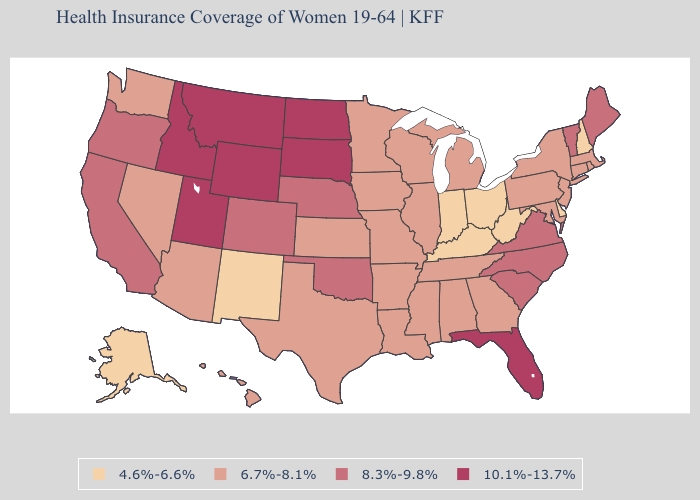Is the legend a continuous bar?
Short answer required. No. Name the states that have a value in the range 10.1%-13.7%?
Answer briefly. Florida, Idaho, Montana, North Dakota, South Dakota, Utah, Wyoming. What is the lowest value in the USA?
Keep it brief. 4.6%-6.6%. Name the states that have a value in the range 4.6%-6.6%?
Keep it brief. Alaska, Delaware, Indiana, Kentucky, New Hampshire, New Mexico, Ohio, West Virginia. What is the value of Delaware?
Give a very brief answer. 4.6%-6.6%. What is the highest value in the USA?
Be succinct. 10.1%-13.7%. Name the states that have a value in the range 6.7%-8.1%?
Answer briefly. Alabama, Arizona, Arkansas, Connecticut, Georgia, Hawaii, Illinois, Iowa, Kansas, Louisiana, Maryland, Massachusetts, Michigan, Minnesota, Mississippi, Missouri, Nevada, New Jersey, New York, Pennsylvania, Rhode Island, Tennessee, Texas, Washington, Wisconsin. What is the value of Montana?
Be succinct. 10.1%-13.7%. What is the lowest value in the MidWest?
Concise answer only. 4.6%-6.6%. What is the value of Louisiana?
Keep it brief. 6.7%-8.1%. What is the value of Montana?
Concise answer only. 10.1%-13.7%. What is the lowest value in the Northeast?
Answer briefly. 4.6%-6.6%. What is the value of West Virginia?
Give a very brief answer. 4.6%-6.6%. Name the states that have a value in the range 6.7%-8.1%?
Give a very brief answer. Alabama, Arizona, Arkansas, Connecticut, Georgia, Hawaii, Illinois, Iowa, Kansas, Louisiana, Maryland, Massachusetts, Michigan, Minnesota, Mississippi, Missouri, Nevada, New Jersey, New York, Pennsylvania, Rhode Island, Tennessee, Texas, Washington, Wisconsin. What is the value of Michigan?
Short answer required. 6.7%-8.1%. 